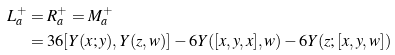<formula> <loc_0><loc_0><loc_500><loc_500>L ^ { + } _ { a } & = R ^ { + } _ { a } = M ^ { + } _ { a } \\ & = 3 6 [ Y ( x ; y ) , Y ( z , w ) ] - 6 Y ( [ x , y , x ] , w ) - 6 Y ( z ; [ x , y , w ] )</formula> 